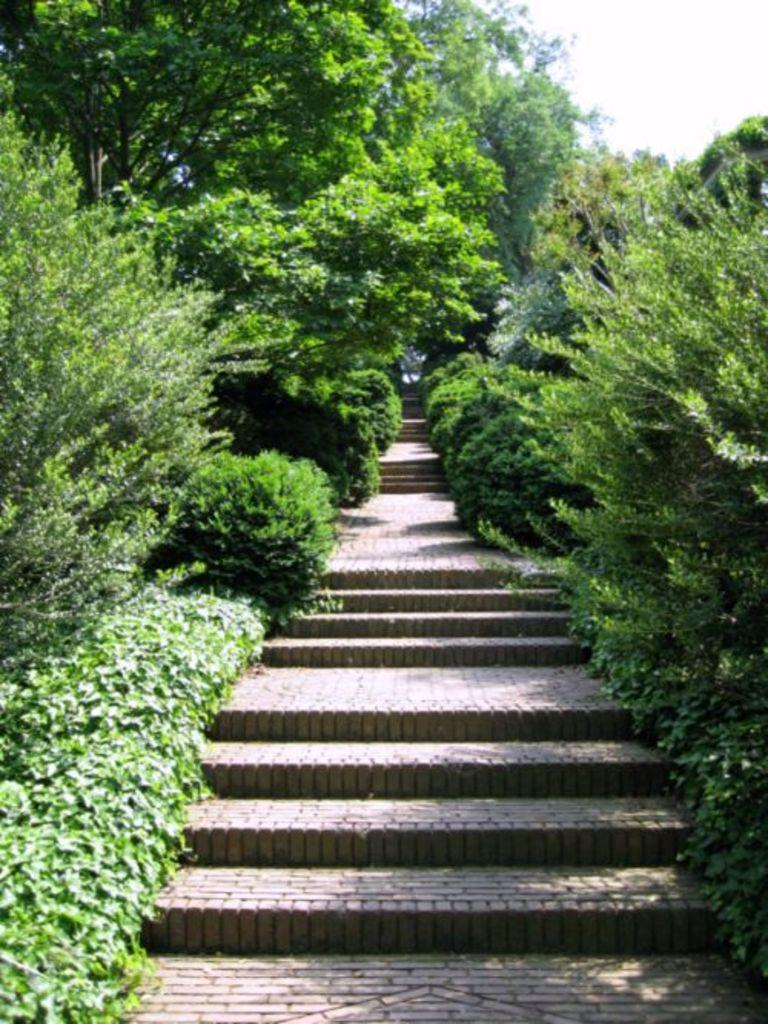What type of stairs are depicted in the image? There are stairs made up of bricks in the image. What is present on both sides of the stairs? The stairs have trees on both sides. What is the color of the trees in the image? The trees are green in color. What can be seen in the background of the image? The sky is visible in the background of the image. What type of jeans is the person wearing while playing chess in the image? There is no person wearing jeans or playing chess in the image; it features stairs with trees on both sides and a green color. 